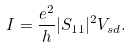<formula> <loc_0><loc_0><loc_500><loc_500>I = \frac { e ^ { 2 } } { h } | S _ { 1 1 } | ^ { 2 } V _ { s d } .</formula> 